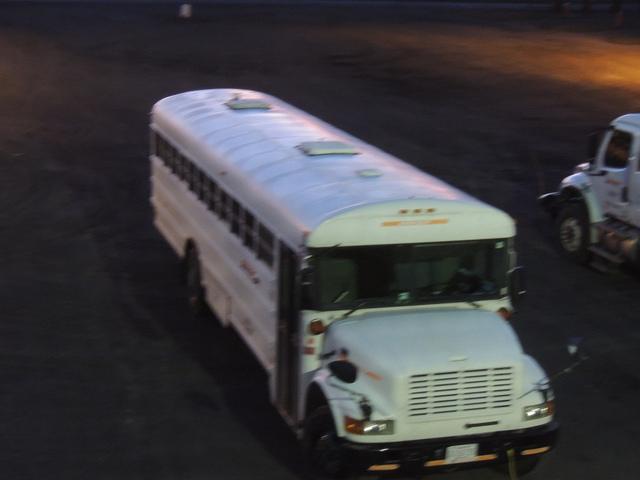What color is this bus?
Give a very brief answer. White. Is this a school bus?
Concise answer only. Yes. How many windows does the vehicle have?
Keep it brief. 15. 